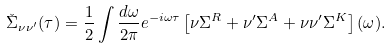<formula> <loc_0><loc_0><loc_500><loc_500>\check { \Sigma } _ { \nu \nu ^ { \prime } } ( \tau ) = \frac { 1 } { 2 } \int \frac { d \omega } { 2 \pi } e ^ { - i \omega \tau } \left [ \nu \Sigma ^ { R } + \nu ^ { \prime } \Sigma ^ { A } + \nu \nu ^ { \prime } \Sigma ^ { K } \right ] ( \omega ) .</formula> 